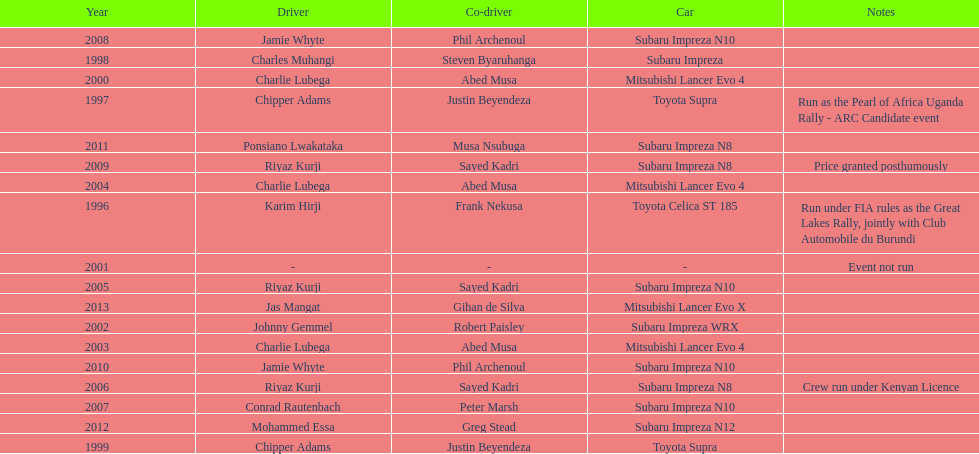Who is the only driver to have consecutive wins? Charlie Lubega. 